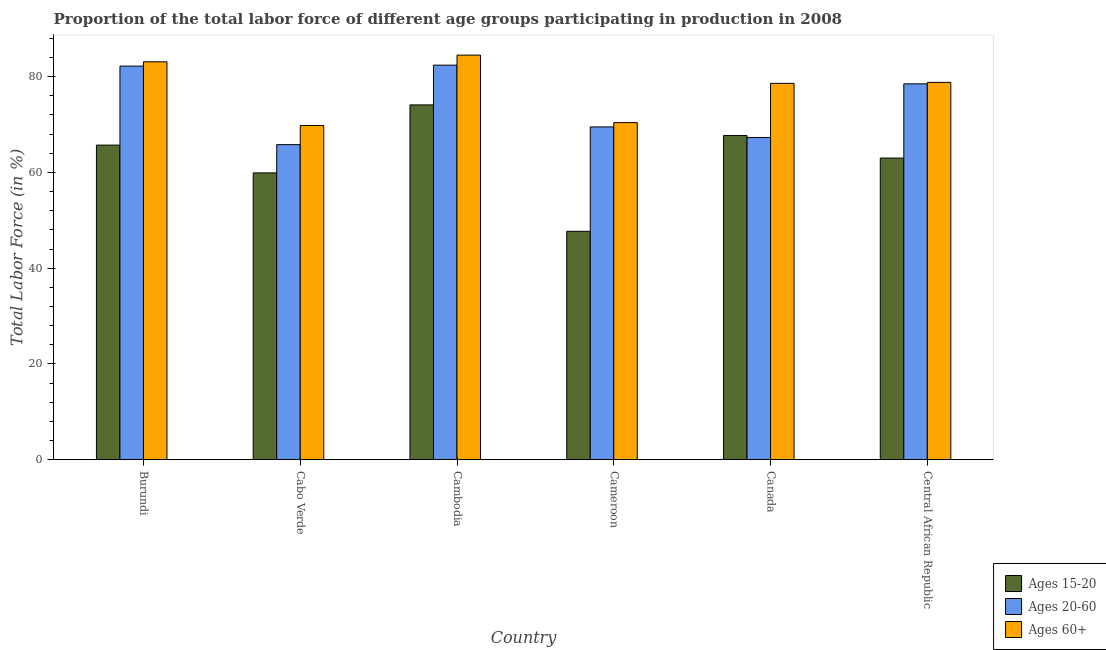How many different coloured bars are there?
Offer a terse response. 3. How many groups of bars are there?
Your response must be concise. 6. Are the number of bars per tick equal to the number of legend labels?
Offer a terse response. Yes. Are the number of bars on each tick of the X-axis equal?
Your answer should be compact. Yes. What is the label of the 2nd group of bars from the left?
Your answer should be very brief. Cabo Verde. In how many cases, is the number of bars for a given country not equal to the number of legend labels?
Your response must be concise. 0. What is the percentage of labor force above age 60 in Canada?
Offer a very short reply. 78.6. Across all countries, what is the maximum percentage of labor force within the age group 15-20?
Your response must be concise. 74.1. Across all countries, what is the minimum percentage of labor force above age 60?
Keep it short and to the point. 69.8. In which country was the percentage of labor force within the age group 15-20 maximum?
Offer a very short reply. Cambodia. In which country was the percentage of labor force above age 60 minimum?
Your answer should be compact. Cabo Verde. What is the total percentage of labor force within the age group 20-60 in the graph?
Offer a terse response. 445.7. What is the difference between the percentage of labor force within the age group 15-20 in Burundi and that in Cabo Verde?
Your answer should be very brief. 5.8. What is the difference between the percentage of labor force above age 60 in Central African Republic and the percentage of labor force within the age group 15-20 in Cabo Verde?
Give a very brief answer. 18.9. What is the average percentage of labor force within the age group 15-20 per country?
Your answer should be compact. 63.02. What is the difference between the percentage of labor force above age 60 and percentage of labor force within the age group 15-20 in Burundi?
Ensure brevity in your answer.  17.4. What is the ratio of the percentage of labor force above age 60 in Cambodia to that in Cameroon?
Provide a short and direct response. 1.2. What is the difference between the highest and the second highest percentage of labor force within the age group 15-20?
Your answer should be compact. 6.4. What is the difference between the highest and the lowest percentage of labor force within the age group 20-60?
Ensure brevity in your answer.  16.6. What does the 1st bar from the left in Cambodia represents?
Offer a terse response. Ages 15-20. What does the 3rd bar from the right in Central African Republic represents?
Offer a terse response. Ages 15-20. Is it the case that in every country, the sum of the percentage of labor force within the age group 15-20 and percentage of labor force within the age group 20-60 is greater than the percentage of labor force above age 60?
Provide a succinct answer. Yes. Are the values on the major ticks of Y-axis written in scientific E-notation?
Provide a succinct answer. No. Does the graph contain grids?
Make the answer very short. No. Where does the legend appear in the graph?
Give a very brief answer. Bottom right. What is the title of the graph?
Provide a short and direct response. Proportion of the total labor force of different age groups participating in production in 2008. Does "Tertiary" appear as one of the legend labels in the graph?
Provide a short and direct response. No. What is the label or title of the Y-axis?
Offer a very short reply. Total Labor Force (in %). What is the Total Labor Force (in %) in Ages 15-20 in Burundi?
Offer a terse response. 65.7. What is the Total Labor Force (in %) in Ages 20-60 in Burundi?
Give a very brief answer. 82.2. What is the Total Labor Force (in %) in Ages 60+ in Burundi?
Provide a short and direct response. 83.1. What is the Total Labor Force (in %) in Ages 15-20 in Cabo Verde?
Give a very brief answer. 59.9. What is the Total Labor Force (in %) in Ages 20-60 in Cabo Verde?
Offer a terse response. 65.8. What is the Total Labor Force (in %) of Ages 60+ in Cabo Verde?
Give a very brief answer. 69.8. What is the Total Labor Force (in %) in Ages 15-20 in Cambodia?
Your response must be concise. 74.1. What is the Total Labor Force (in %) of Ages 20-60 in Cambodia?
Offer a terse response. 82.4. What is the Total Labor Force (in %) of Ages 60+ in Cambodia?
Ensure brevity in your answer.  84.5. What is the Total Labor Force (in %) in Ages 15-20 in Cameroon?
Ensure brevity in your answer.  47.7. What is the Total Labor Force (in %) in Ages 20-60 in Cameroon?
Your answer should be very brief. 69.5. What is the Total Labor Force (in %) of Ages 60+ in Cameroon?
Offer a very short reply. 70.4. What is the Total Labor Force (in %) of Ages 15-20 in Canada?
Make the answer very short. 67.7. What is the Total Labor Force (in %) in Ages 20-60 in Canada?
Ensure brevity in your answer.  67.3. What is the Total Labor Force (in %) of Ages 60+ in Canada?
Offer a terse response. 78.6. What is the Total Labor Force (in %) in Ages 15-20 in Central African Republic?
Your answer should be very brief. 63. What is the Total Labor Force (in %) of Ages 20-60 in Central African Republic?
Offer a very short reply. 78.5. What is the Total Labor Force (in %) of Ages 60+ in Central African Republic?
Your answer should be compact. 78.8. Across all countries, what is the maximum Total Labor Force (in %) of Ages 15-20?
Offer a very short reply. 74.1. Across all countries, what is the maximum Total Labor Force (in %) in Ages 20-60?
Provide a succinct answer. 82.4. Across all countries, what is the maximum Total Labor Force (in %) in Ages 60+?
Ensure brevity in your answer.  84.5. Across all countries, what is the minimum Total Labor Force (in %) in Ages 15-20?
Provide a succinct answer. 47.7. Across all countries, what is the minimum Total Labor Force (in %) in Ages 20-60?
Offer a terse response. 65.8. Across all countries, what is the minimum Total Labor Force (in %) in Ages 60+?
Provide a succinct answer. 69.8. What is the total Total Labor Force (in %) of Ages 15-20 in the graph?
Make the answer very short. 378.1. What is the total Total Labor Force (in %) in Ages 20-60 in the graph?
Provide a succinct answer. 445.7. What is the total Total Labor Force (in %) of Ages 60+ in the graph?
Your response must be concise. 465.2. What is the difference between the Total Labor Force (in %) of Ages 20-60 in Burundi and that in Cabo Verde?
Your answer should be very brief. 16.4. What is the difference between the Total Labor Force (in %) of Ages 15-20 in Burundi and that in Cambodia?
Provide a short and direct response. -8.4. What is the difference between the Total Labor Force (in %) of Ages 15-20 in Burundi and that in Cameroon?
Offer a very short reply. 18. What is the difference between the Total Labor Force (in %) in Ages 20-60 in Burundi and that in Cameroon?
Make the answer very short. 12.7. What is the difference between the Total Labor Force (in %) of Ages 60+ in Burundi and that in Canada?
Your answer should be compact. 4.5. What is the difference between the Total Labor Force (in %) of Ages 20-60 in Burundi and that in Central African Republic?
Your answer should be compact. 3.7. What is the difference between the Total Labor Force (in %) of Ages 60+ in Burundi and that in Central African Republic?
Ensure brevity in your answer.  4.3. What is the difference between the Total Labor Force (in %) in Ages 15-20 in Cabo Verde and that in Cambodia?
Offer a terse response. -14.2. What is the difference between the Total Labor Force (in %) of Ages 20-60 in Cabo Verde and that in Cambodia?
Keep it short and to the point. -16.6. What is the difference between the Total Labor Force (in %) in Ages 60+ in Cabo Verde and that in Cambodia?
Your answer should be compact. -14.7. What is the difference between the Total Labor Force (in %) in Ages 20-60 in Cabo Verde and that in Cameroon?
Provide a succinct answer. -3.7. What is the difference between the Total Labor Force (in %) of Ages 60+ in Cabo Verde and that in Cameroon?
Your response must be concise. -0.6. What is the difference between the Total Labor Force (in %) of Ages 15-20 in Cabo Verde and that in Canada?
Your answer should be compact. -7.8. What is the difference between the Total Labor Force (in %) in Ages 20-60 in Cabo Verde and that in Canada?
Provide a succinct answer. -1.5. What is the difference between the Total Labor Force (in %) of Ages 15-20 in Cambodia and that in Cameroon?
Offer a very short reply. 26.4. What is the difference between the Total Labor Force (in %) in Ages 20-60 in Cambodia and that in Cameroon?
Provide a short and direct response. 12.9. What is the difference between the Total Labor Force (in %) of Ages 20-60 in Cambodia and that in Central African Republic?
Your answer should be compact. 3.9. What is the difference between the Total Labor Force (in %) in Ages 15-20 in Cameroon and that in Canada?
Your answer should be compact. -20. What is the difference between the Total Labor Force (in %) in Ages 20-60 in Cameroon and that in Canada?
Your answer should be compact. 2.2. What is the difference between the Total Labor Force (in %) in Ages 60+ in Cameroon and that in Canada?
Your answer should be compact. -8.2. What is the difference between the Total Labor Force (in %) of Ages 15-20 in Cameroon and that in Central African Republic?
Keep it short and to the point. -15.3. What is the difference between the Total Labor Force (in %) of Ages 15-20 in Burundi and the Total Labor Force (in %) of Ages 20-60 in Cabo Verde?
Your answer should be very brief. -0.1. What is the difference between the Total Labor Force (in %) of Ages 15-20 in Burundi and the Total Labor Force (in %) of Ages 20-60 in Cambodia?
Your answer should be very brief. -16.7. What is the difference between the Total Labor Force (in %) of Ages 15-20 in Burundi and the Total Labor Force (in %) of Ages 60+ in Cambodia?
Ensure brevity in your answer.  -18.8. What is the difference between the Total Labor Force (in %) in Ages 15-20 in Burundi and the Total Labor Force (in %) in Ages 60+ in Cameroon?
Your answer should be compact. -4.7. What is the difference between the Total Labor Force (in %) in Ages 15-20 in Burundi and the Total Labor Force (in %) in Ages 20-60 in Canada?
Provide a succinct answer. -1.6. What is the difference between the Total Labor Force (in %) of Ages 15-20 in Burundi and the Total Labor Force (in %) of Ages 20-60 in Central African Republic?
Offer a very short reply. -12.8. What is the difference between the Total Labor Force (in %) in Ages 15-20 in Burundi and the Total Labor Force (in %) in Ages 60+ in Central African Republic?
Provide a short and direct response. -13.1. What is the difference between the Total Labor Force (in %) in Ages 20-60 in Burundi and the Total Labor Force (in %) in Ages 60+ in Central African Republic?
Give a very brief answer. 3.4. What is the difference between the Total Labor Force (in %) of Ages 15-20 in Cabo Verde and the Total Labor Force (in %) of Ages 20-60 in Cambodia?
Make the answer very short. -22.5. What is the difference between the Total Labor Force (in %) in Ages 15-20 in Cabo Verde and the Total Labor Force (in %) in Ages 60+ in Cambodia?
Ensure brevity in your answer.  -24.6. What is the difference between the Total Labor Force (in %) in Ages 20-60 in Cabo Verde and the Total Labor Force (in %) in Ages 60+ in Cambodia?
Your answer should be very brief. -18.7. What is the difference between the Total Labor Force (in %) of Ages 15-20 in Cabo Verde and the Total Labor Force (in %) of Ages 60+ in Cameroon?
Your response must be concise. -10.5. What is the difference between the Total Labor Force (in %) of Ages 20-60 in Cabo Verde and the Total Labor Force (in %) of Ages 60+ in Cameroon?
Offer a terse response. -4.6. What is the difference between the Total Labor Force (in %) in Ages 15-20 in Cabo Verde and the Total Labor Force (in %) in Ages 60+ in Canada?
Offer a very short reply. -18.7. What is the difference between the Total Labor Force (in %) in Ages 20-60 in Cabo Verde and the Total Labor Force (in %) in Ages 60+ in Canada?
Make the answer very short. -12.8. What is the difference between the Total Labor Force (in %) in Ages 15-20 in Cabo Verde and the Total Labor Force (in %) in Ages 20-60 in Central African Republic?
Your answer should be very brief. -18.6. What is the difference between the Total Labor Force (in %) in Ages 15-20 in Cabo Verde and the Total Labor Force (in %) in Ages 60+ in Central African Republic?
Provide a short and direct response. -18.9. What is the difference between the Total Labor Force (in %) of Ages 15-20 in Cambodia and the Total Labor Force (in %) of Ages 20-60 in Cameroon?
Offer a very short reply. 4.6. What is the difference between the Total Labor Force (in %) of Ages 15-20 in Cambodia and the Total Labor Force (in %) of Ages 60+ in Cameroon?
Your answer should be compact. 3.7. What is the difference between the Total Labor Force (in %) in Ages 20-60 in Cambodia and the Total Labor Force (in %) in Ages 60+ in Cameroon?
Give a very brief answer. 12. What is the difference between the Total Labor Force (in %) in Ages 15-20 in Cambodia and the Total Labor Force (in %) in Ages 20-60 in Canada?
Provide a short and direct response. 6.8. What is the difference between the Total Labor Force (in %) in Ages 15-20 in Cambodia and the Total Labor Force (in %) in Ages 60+ in Canada?
Make the answer very short. -4.5. What is the difference between the Total Labor Force (in %) in Ages 15-20 in Cambodia and the Total Labor Force (in %) in Ages 20-60 in Central African Republic?
Your response must be concise. -4.4. What is the difference between the Total Labor Force (in %) in Ages 15-20 in Cameroon and the Total Labor Force (in %) in Ages 20-60 in Canada?
Provide a short and direct response. -19.6. What is the difference between the Total Labor Force (in %) in Ages 15-20 in Cameroon and the Total Labor Force (in %) in Ages 60+ in Canada?
Make the answer very short. -30.9. What is the difference between the Total Labor Force (in %) of Ages 15-20 in Cameroon and the Total Labor Force (in %) of Ages 20-60 in Central African Republic?
Your answer should be very brief. -30.8. What is the difference between the Total Labor Force (in %) in Ages 15-20 in Cameroon and the Total Labor Force (in %) in Ages 60+ in Central African Republic?
Your response must be concise. -31.1. What is the difference between the Total Labor Force (in %) of Ages 15-20 in Canada and the Total Labor Force (in %) of Ages 20-60 in Central African Republic?
Keep it short and to the point. -10.8. What is the average Total Labor Force (in %) in Ages 15-20 per country?
Keep it short and to the point. 63.02. What is the average Total Labor Force (in %) of Ages 20-60 per country?
Your response must be concise. 74.28. What is the average Total Labor Force (in %) in Ages 60+ per country?
Your response must be concise. 77.53. What is the difference between the Total Labor Force (in %) of Ages 15-20 and Total Labor Force (in %) of Ages 20-60 in Burundi?
Your answer should be very brief. -16.5. What is the difference between the Total Labor Force (in %) in Ages 15-20 and Total Labor Force (in %) in Ages 60+ in Burundi?
Your answer should be compact. -17.4. What is the difference between the Total Labor Force (in %) of Ages 20-60 and Total Labor Force (in %) of Ages 60+ in Burundi?
Ensure brevity in your answer.  -0.9. What is the difference between the Total Labor Force (in %) of Ages 20-60 and Total Labor Force (in %) of Ages 60+ in Cabo Verde?
Provide a short and direct response. -4. What is the difference between the Total Labor Force (in %) of Ages 15-20 and Total Labor Force (in %) of Ages 60+ in Cambodia?
Keep it short and to the point. -10.4. What is the difference between the Total Labor Force (in %) of Ages 20-60 and Total Labor Force (in %) of Ages 60+ in Cambodia?
Give a very brief answer. -2.1. What is the difference between the Total Labor Force (in %) in Ages 15-20 and Total Labor Force (in %) in Ages 20-60 in Cameroon?
Offer a very short reply. -21.8. What is the difference between the Total Labor Force (in %) of Ages 15-20 and Total Labor Force (in %) of Ages 60+ in Cameroon?
Provide a short and direct response. -22.7. What is the difference between the Total Labor Force (in %) of Ages 15-20 and Total Labor Force (in %) of Ages 60+ in Canada?
Ensure brevity in your answer.  -10.9. What is the difference between the Total Labor Force (in %) in Ages 15-20 and Total Labor Force (in %) in Ages 20-60 in Central African Republic?
Your answer should be very brief. -15.5. What is the difference between the Total Labor Force (in %) in Ages 15-20 and Total Labor Force (in %) in Ages 60+ in Central African Republic?
Keep it short and to the point. -15.8. What is the ratio of the Total Labor Force (in %) of Ages 15-20 in Burundi to that in Cabo Verde?
Your answer should be very brief. 1.1. What is the ratio of the Total Labor Force (in %) of Ages 20-60 in Burundi to that in Cabo Verde?
Make the answer very short. 1.25. What is the ratio of the Total Labor Force (in %) of Ages 60+ in Burundi to that in Cabo Verde?
Offer a very short reply. 1.19. What is the ratio of the Total Labor Force (in %) of Ages 15-20 in Burundi to that in Cambodia?
Ensure brevity in your answer.  0.89. What is the ratio of the Total Labor Force (in %) of Ages 60+ in Burundi to that in Cambodia?
Make the answer very short. 0.98. What is the ratio of the Total Labor Force (in %) in Ages 15-20 in Burundi to that in Cameroon?
Offer a very short reply. 1.38. What is the ratio of the Total Labor Force (in %) in Ages 20-60 in Burundi to that in Cameroon?
Offer a terse response. 1.18. What is the ratio of the Total Labor Force (in %) in Ages 60+ in Burundi to that in Cameroon?
Offer a very short reply. 1.18. What is the ratio of the Total Labor Force (in %) in Ages 15-20 in Burundi to that in Canada?
Provide a succinct answer. 0.97. What is the ratio of the Total Labor Force (in %) of Ages 20-60 in Burundi to that in Canada?
Provide a succinct answer. 1.22. What is the ratio of the Total Labor Force (in %) of Ages 60+ in Burundi to that in Canada?
Provide a short and direct response. 1.06. What is the ratio of the Total Labor Force (in %) in Ages 15-20 in Burundi to that in Central African Republic?
Ensure brevity in your answer.  1.04. What is the ratio of the Total Labor Force (in %) in Ages 20-60 in Burundi to that in Central African Republic?
Keep it short and to the point. 1.05. What is the ratio of the Total Labor Force (in %) in Ages 60+ in Burundi to that in Central African Republic?
Your answer should be very brief. 1.05. What is the ratio of the Total Labor Force (in %) in Ages 15-20 in Cabo Verde to that in Cambodia?
Your answer should be compact. 0.81. What is the ratio of the Total Labor Force (in %) in Ages 20-60 in Cabo Verde to that in Cambodia?
Make the answer very short. 0.8. What is the ratio of the Total Labor Force (in %) of Ages 60+ in Cabo Verde to that in Cambodia?
Ensure brevity in your answer.  0.83. What is the ratio of the Total Labor Force (in %) of Ages 15-20 in Cabo Verde to that in Cameroon?
Provide a short and direct response. 1.26. What is the ratio of the Total Labor Force (in %) of Ages 20-60 in Cabo Verde to that in Cameroon?
Give a very brief answer. 0.95. What is the ratio of the Total Labor Force (in %) in Ages 60+ in Cabo Verde to that in Cameroon?
Provide a succinct answer. 0.99. What is the ratio of the Total Labor Force (in %) in Ages 15-20 in Cabo Verde to that in Canada?
Provide a short and direct response. 0.88. What is the ratio of the Total Labor Force (in %) in Ages 20-60 in Cabo Verde to that in Canada?
Give a very brief answer. 0.98. What is the ratio of the Total Labor Force (in %) of Ages 60+ in Cabo Verde to that in Canada?
Your answer should be compact. 0.89. What is the ratio of the Total Labor Force (in %) in Ages 15-20 in Cabo Verde to that in Central African Republic?
Your answer should be very brief. 0.95. What is the ratio of the Total Labor Force (in %) in Ages 20-60 in Cabo Verde to that in Central African Republic?
Offer a terse response. 0.84. What is the ratio of the Total Labor Force (in %) of Ages 60+ in Cabo Verde to that in Central African Republic?
Keep it short and to the point. 0.89. What is the ratio of the Total Labor Force (in %) of Ages 15-20 in Cambodia to that in Cameroon?
Provide a short and direct response. 1.55. What is the ratio of the Total Labor Force (in %) in Ages 20-60 in Cambodia to that in Cameroon?
Offer a terse response. 1.19. What is the ratio of the Total Labor Force (in %) in Ages 60+ in Cambodia to that in Cameroon?
Your response must be concise. 1.2. What is the ratio of the Total Labor Force (in %) in Ages 15-20 in Cambodia to that in Canada?
Your answer should be compact. 1.09. What is the ratio of the Total Labor Force (in %) of Ages 20-60 in Cambodia to that in Canada?
Give a very brief answer. 1.22. What is the ratio of the Total Labor Force (in %) in Ages 60+ in Cambodia to that in Canada?
Your response must be concise. 1.08. What is the ratio of the Total Labor Force (in %) of Ages 15-20 in Cambodia to that in Central African Republic?
Offer a very short reply. 1.18. What is the ratio of the Total Labor Force (in %) of Ages 20-60 in Cambodia to that in Central African Republic?
Your answer should be compact. 1.05. What is the ratio of the Total Labor Force (in %) of Ages 60+ in Cambodia to that in Central African Republic?
Your answer should be very brief. 1.07. What is the ratio of the Total Labor Force (in %) of Ages 15-20 in Cameroon to that in Canada?
Ensure brevity in your answer.  0.7. What is the ratio of the Total Labor Force (in %) of Ages 20-60 in Cameroon to that in Canada?
Make the answer very short. 1.03. What is the ratio of the Total Labor Force (in %) in Ages 60+ in Cameroon to that in Canada?
Ensure brevity in your answer.  0.9. What is the ratio of the Total Labor Force (in %) in Ages 15-20 in Cameroon to that in Central African Republic?
Provide a short and direct response. 0.76. What is the ratio of the Total Labor Force (in %) in Ages 20-60 in Cameroon to that in Central African Republic?
Your answer should be very brief. 0.89. What is the ratio of the Total Labor Force (in %) in Ages 60+ in Cameroon to that in Central African Republic?
Offer a terse response. 0.89. What is the ratio of the Total Labor Force (in %) of Ages 15-20 in Canada to that in Central African Republic?
Your response must be concise. 1.07. What is the ratio of the Total Labor Force (in %) of Ages 20-60 in Canada to that in Central African Republic?
Your response must be concise. 0.86. What is the difference between the highest and the second highest Total Labor Force (in %) of Ages 15-20?
Your answer should be very brief. 6.4. What is the difference between the highest and the lowest Total Labor Force (in %) of Ages 15-20?
Your answer should be compact. 26.4. What is the difference between the highest and the lowest Total Labor Force (in %) in Ages 20-60?
Provide a succinct answer. 16.6. 